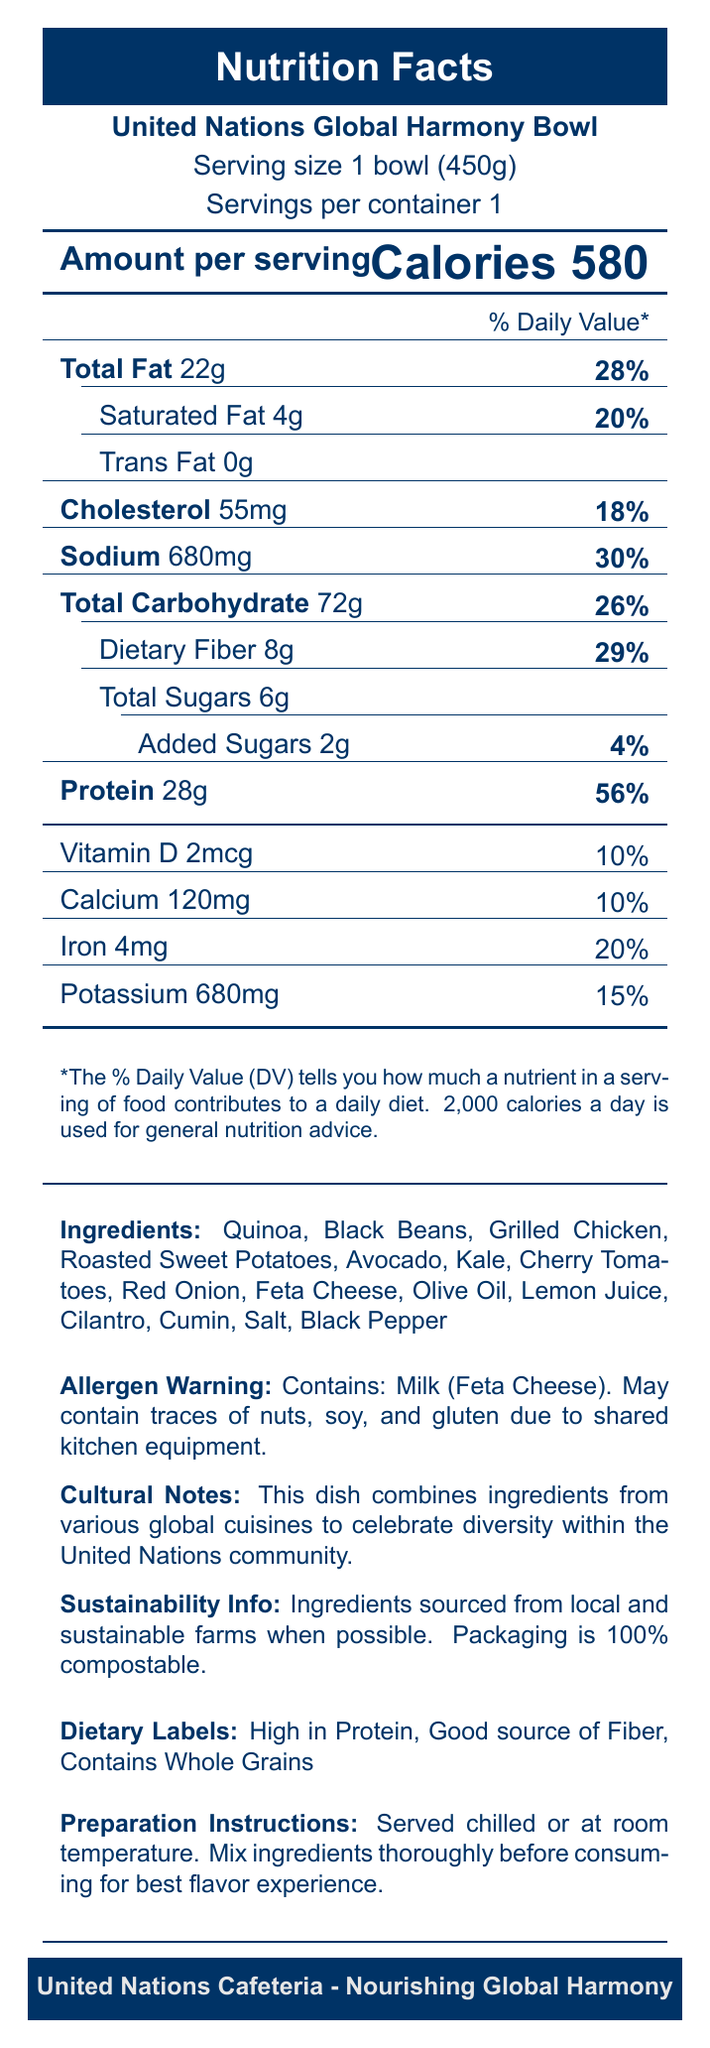what is the serving size of the United Nations Global Harmony Bowl? The document specifies that the serving size is one bowl weighing 450 grams.
Answer: 1 bowl (450g) what is the amount of cholesterol in one serving? According to the document, one serving contains 55 milligrams of cholesterol.
Answer: 55mg how much dietary fiber does one serving provide? The document states that one serving provides 8 grams of dietary fiber.
Answer: 8g which ingredient contains the allergen listed in the warning? The document mentions that milk (Feta Cheese) is the allergen in the warning.
Answer: Feta Cheese what is the percentage daily value for protein? The document indicates that one serving provides 56% of the daily value for protein.
Answer: 56% what is the total carbohydrate content in the Global Harmony Bowl? The document shows that the total carbohydrate content is 72 grams.
Answer: 72g how many grams of total sugars are in one serving? The document states that there are 6 grams of total sugars in one serving.
Answer: 6g which nutrient(s) have a daily value percentage listed as 10%? A. Vitamin D B. Calcium C. Iron D. A and B Both Vitamin D and Calcium have a daily value percentage listed as 10% in the document.
Answer: D which of the following is NOT listed as an ingredient? A. Kale B. Tofu C. Cilantro D. Grilled Chicken Tofu is not listed as an ingredient in the document; Kale, Cilantro, and Grilled Chicken are listed.
Answer: B is the packaging for the Global Harmony Bowl compostable? The document states that the packaging is 100% compostable.
Answer: Yes summarize the main idea of the document. The document gives comprehensive information about a meal offered at the UN cafeteria, including its nutritional value, ingredients, potential allergens, cultural and sustainability notes, and dietary benefits.
Answer: The document provides nutrition facts, ingredients, allergen warnings, cultural notes, sustainability information, and dietary labels for the United Nations Global Harmony Bowl. what is the source of sodium in the dish? The document lists the amount of sodium but does not specify the source of sodium in the ingredients.
Answer: Not enough information what dietary labels are assigned to the Global Harmony Bowl? The document mentions these three dietary labels.
Answer: High in Protein, Good source of Fiber, Contains Whole Grains is there any trans fat in the dish? The document specifies that the amount of trans fat is 0 grams.
Answer: No what percentage of daily value for saturated fat does one serving provide? The document states that one serving provides 20% of the daily value for saturated fat.
Answer: 20% 